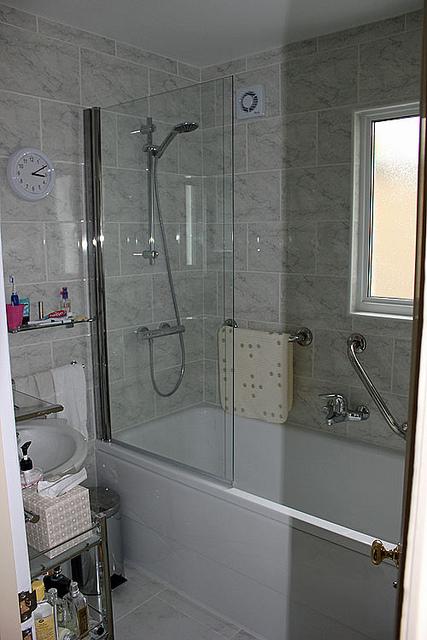What is the item hanging over the rod inside the shower area?
Keep it brief. Towel. Does the shower have a glass door?
Write a very short answer. Yes. Why is the bath mat hanging in the shower?
Concise answer only. To dry. 